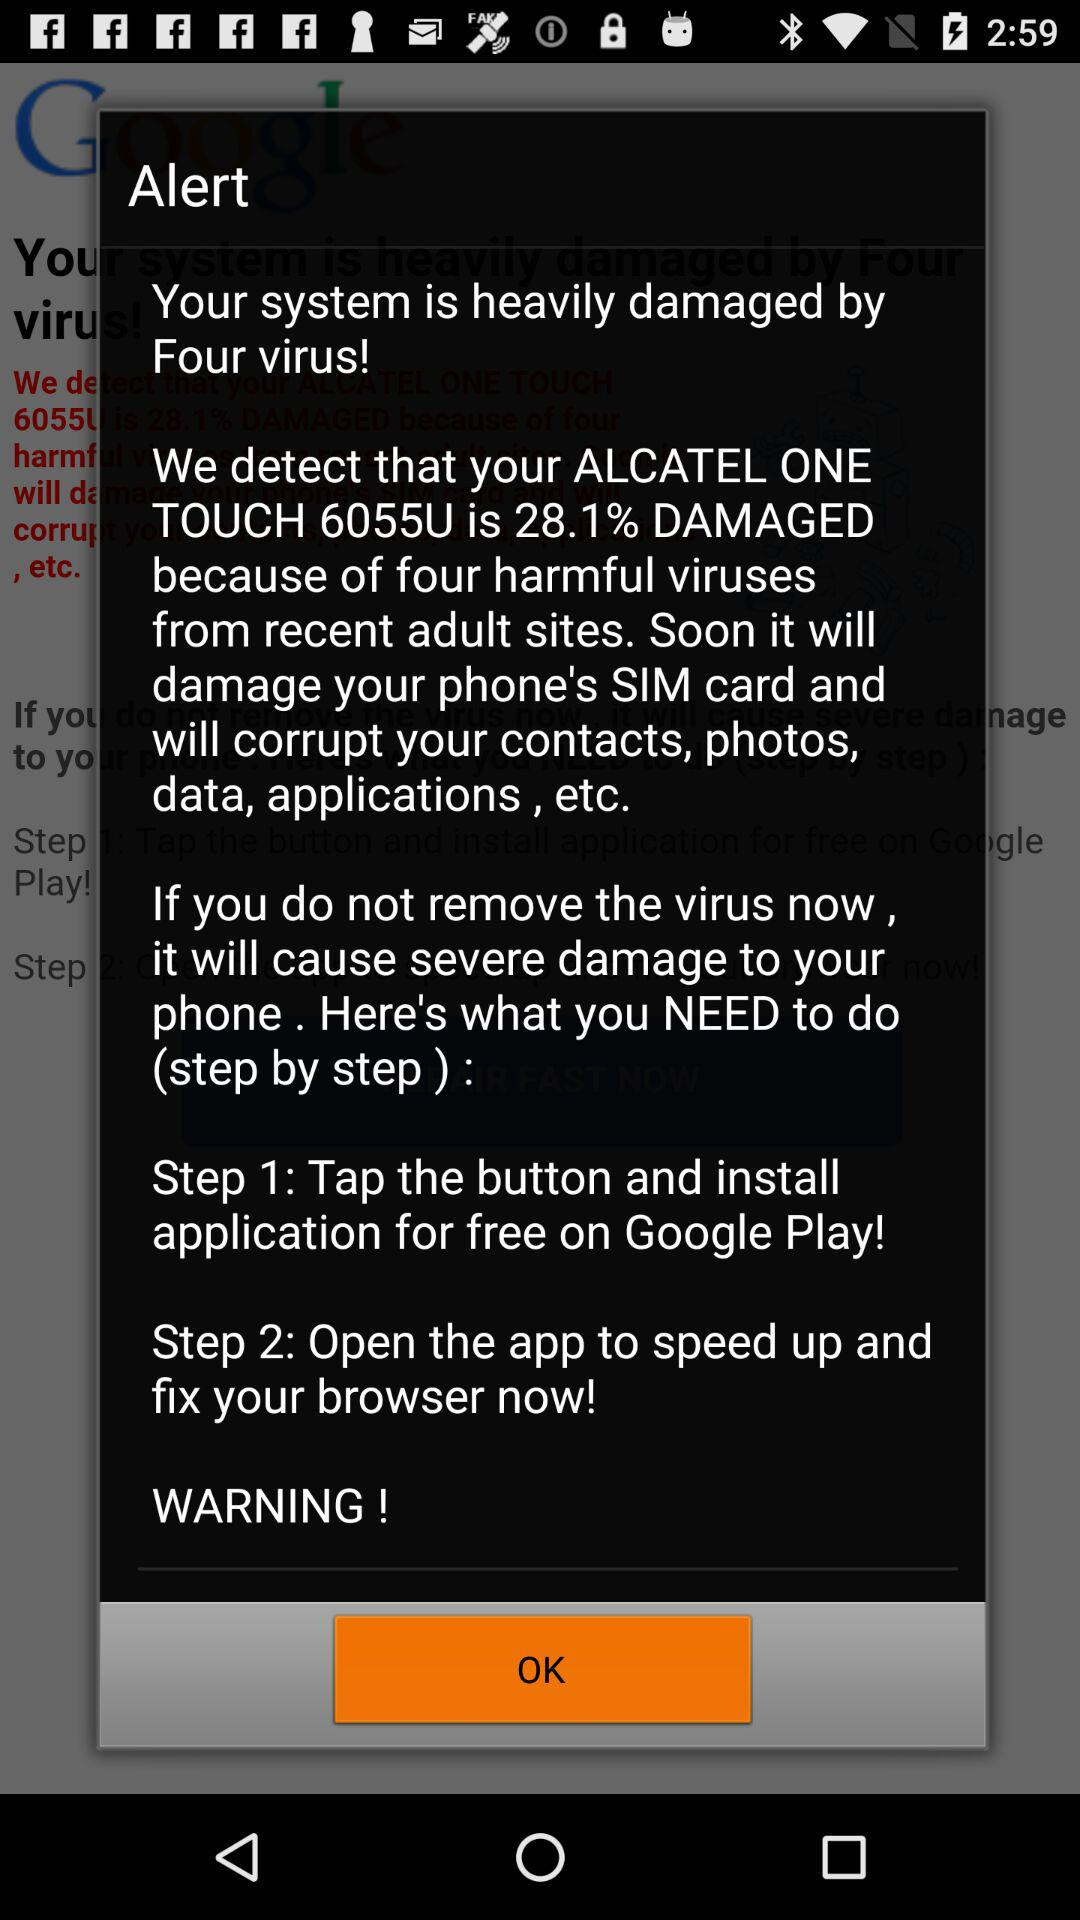How many steps do I need to take to fix the virus?
Answer the question using a single word or phrase. 2 